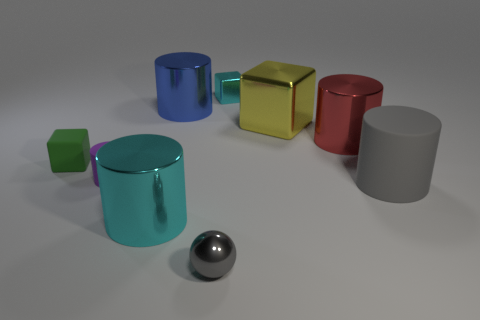What number of cubes are large gray matte things or large red metal things?
Offer a very short reply. 0. There is a matte thing that is both right of the green rubber thing and on the left side of the big cyan cylinder; what is its shape?
Provide a succinct answer. Cylinder. Are there an equal number of blocks that are to the right of the red metallic object and gray matte cylinders that are to the left of the cyan cylinder?
Make the answer very short. Yes. How many things are either big purple balls or rubber cylinders?
Offer a very short reply. 2. What color is the ball that is the same size as the green rubber thing?
Your response must be concise. Gray. What number of objects are either cyan metal objects that are behind the yellow metal block or large cylinders in front of the small purple object?
Ensure brevity in your answer.  3. Is the number of small cubes behind the red metallic object the same as the number of large cyan metal things?
Offer a very short reply. Yes. There is a gray object behind the tiny metallic sphere; does it have the same size as the cyan object right of the gray metallic ball?
Ensure brevity in your answer.  No. What number of other objects are there of the same size as the red shiny object?
Your response must be concise. 4. Is there a large gray rubber cylinder that is behind the cyan object behind the cyan object to the left of the tiny cyan object?
Provide a short and direct response. No. 